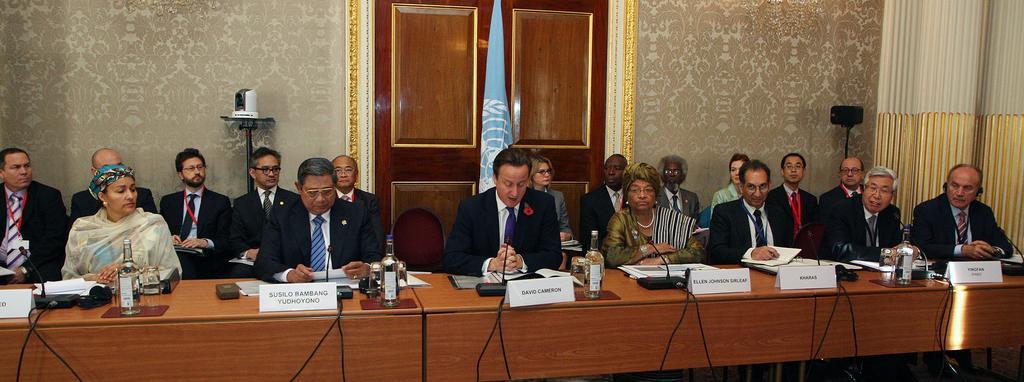How would you summarize this image in a sentence or two? This picture describes about group of people, they are seated on the chairs, in front of them we can find few bottles, name boards, microphones and glasses on the table, and also we can find few files and papers, in the background we can see a flag and a speaker. 